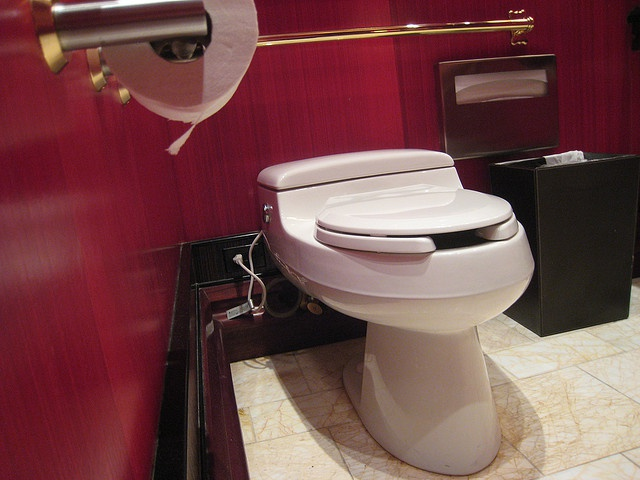Describe the objects in this image and their specific colors. I can see a toilet in maroon, darkgray, lightgray, and gray tones in this image. 